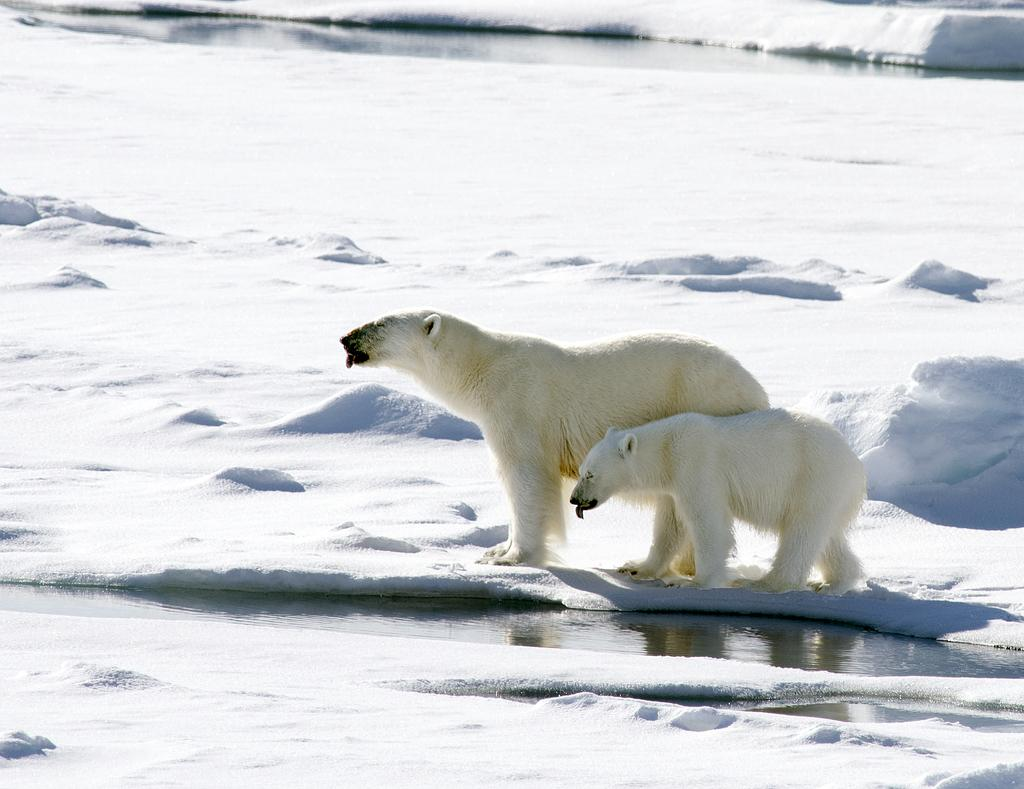What animals are present in the image? There are polar bears in the image. What type of environment is depicted in the image? The image shows a snowy environment. Is there any liquid visible in the image? Yes, there is water in the image. What route do the polar bears take to reach the faucet in the image? There is no faucet present in the image, so the polar bears do not have a route to reach one. 